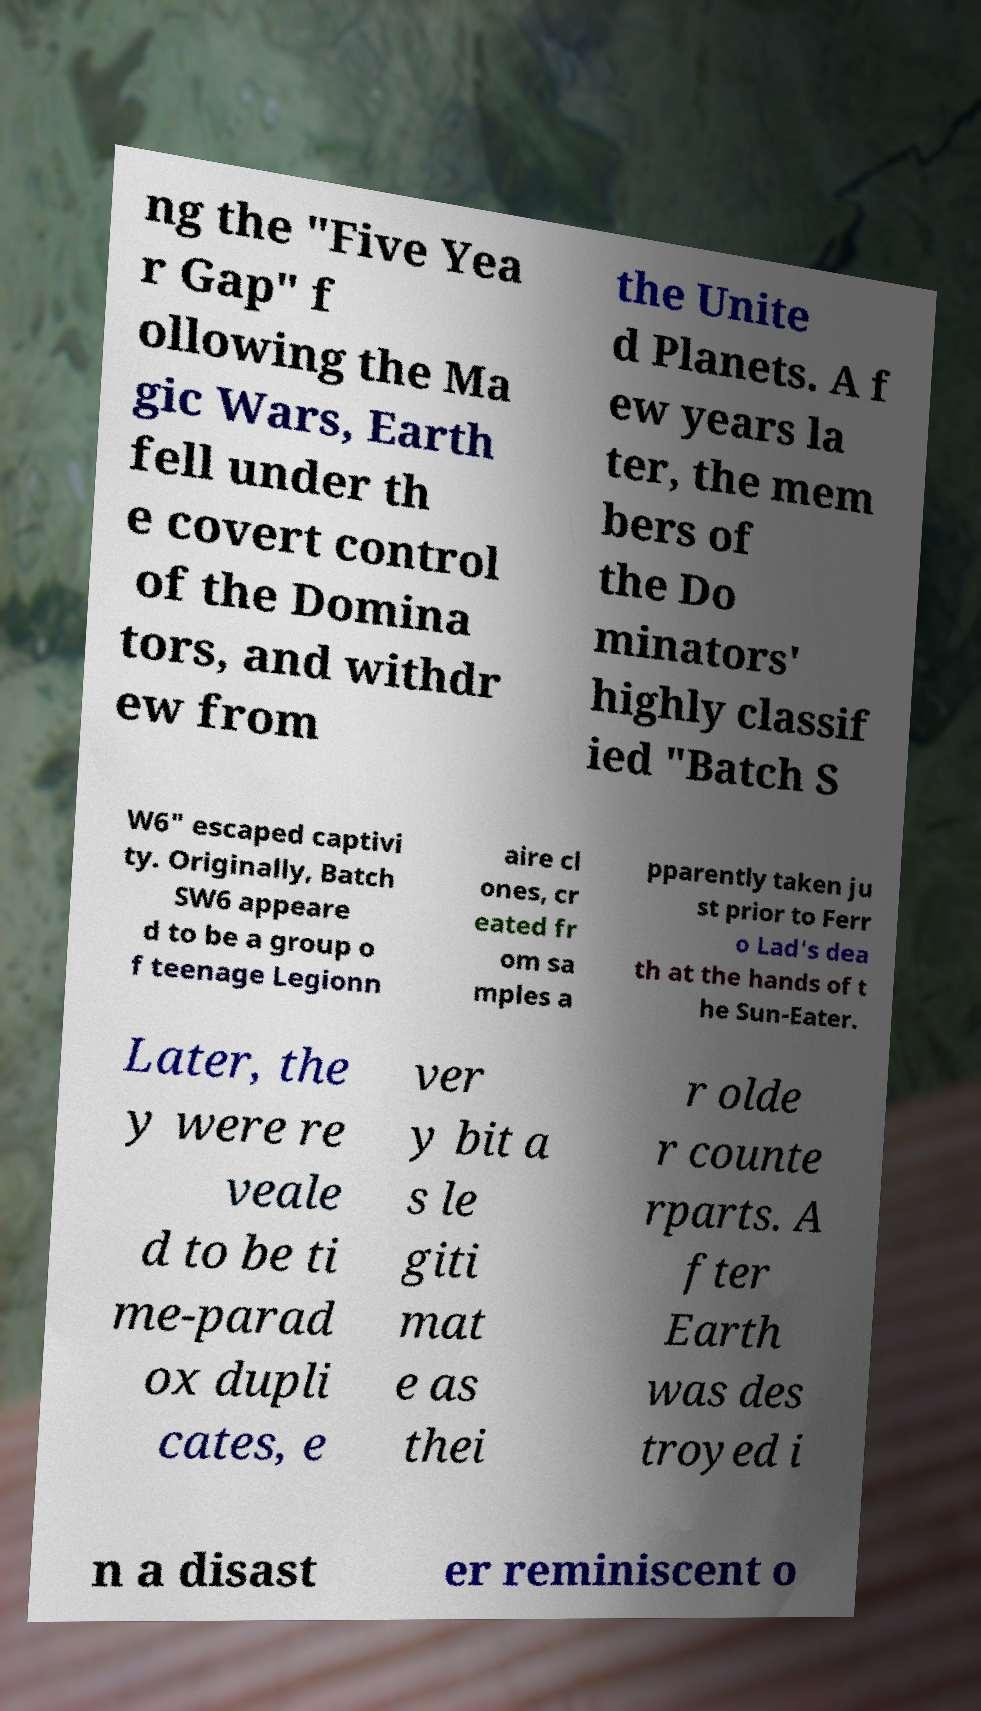I need the written content from this picture converted into text. Can you do that? ng the "Five Yea r Gap" f ollowing the Ma gic Wars, Earth fell under th e covert control of the Domina tors, and withdr ew from the Unite d Planets. A f ew years la ter, the mem bers of the Do minators' highly classif ied "Batch S W6" escaped captivi ty. Originally, Batch SW6 appeare d to be a group o f teenage Legionn aire cl ones, cr eated fr om sa mples a pparently taken ju st prior to Ferr o Lad's dea th at the hands of t he Sun-Eater. Later, the y were re veale d to be ti me-parad ox dupli cates, e ver y bit a s le giti mat e as thei r olde r counte rparts. A fter Earth was des troyed i n a disast er reminiscent o 